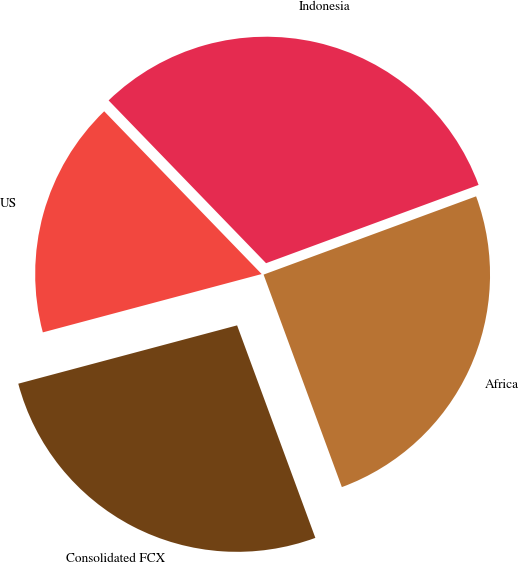Convert chart to OTSL. <chart><loc_0><loc_0><loc_500><loc_500><pie_chart><fcel>US<fcel>Indonesia<fcel>Africa<fcel>Consolidated FCX<nl><fcel>16.91%<fcel>31.62%<fcel>25.0%<fcel>26.47%<nl></chart> 